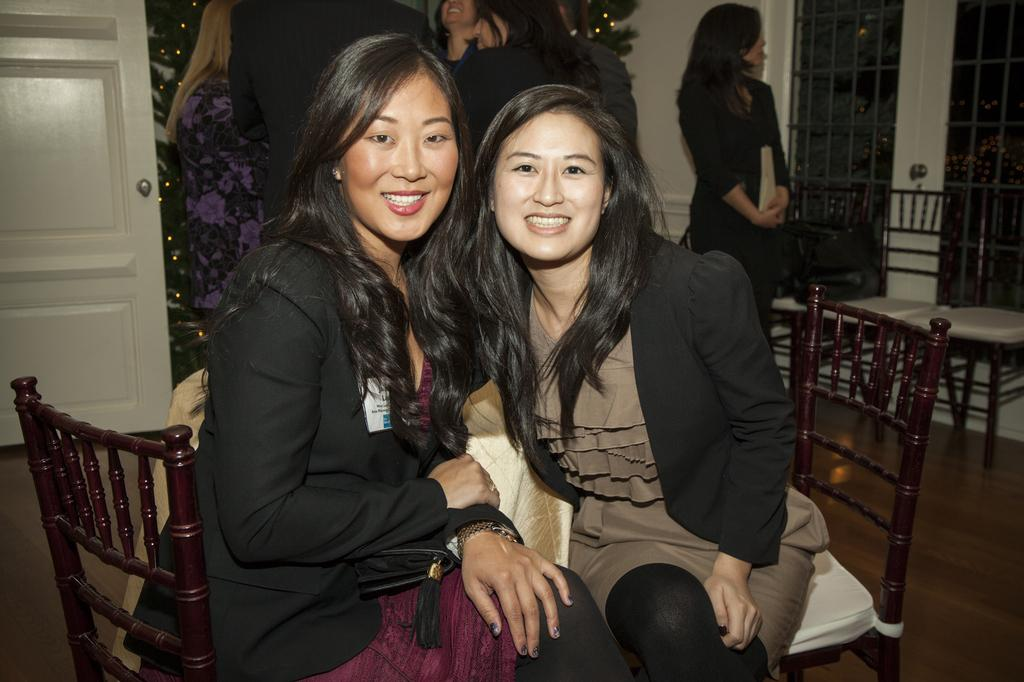How many women are sitting in the image? There are two women sitting on chairs in the image. What are the expressions on the faces of the women? The women are smiling. What can be seen in the background of the image? There is a door visible in the background of the image. What is the standing woman in the background doing? The standing woman is looking at something. What type of yarn is the woman in the background knitting in the image? There is no yarn or knitting activity present in the image. What class are the women attending in the image? There is no indication of a class or educational setting in the image. 